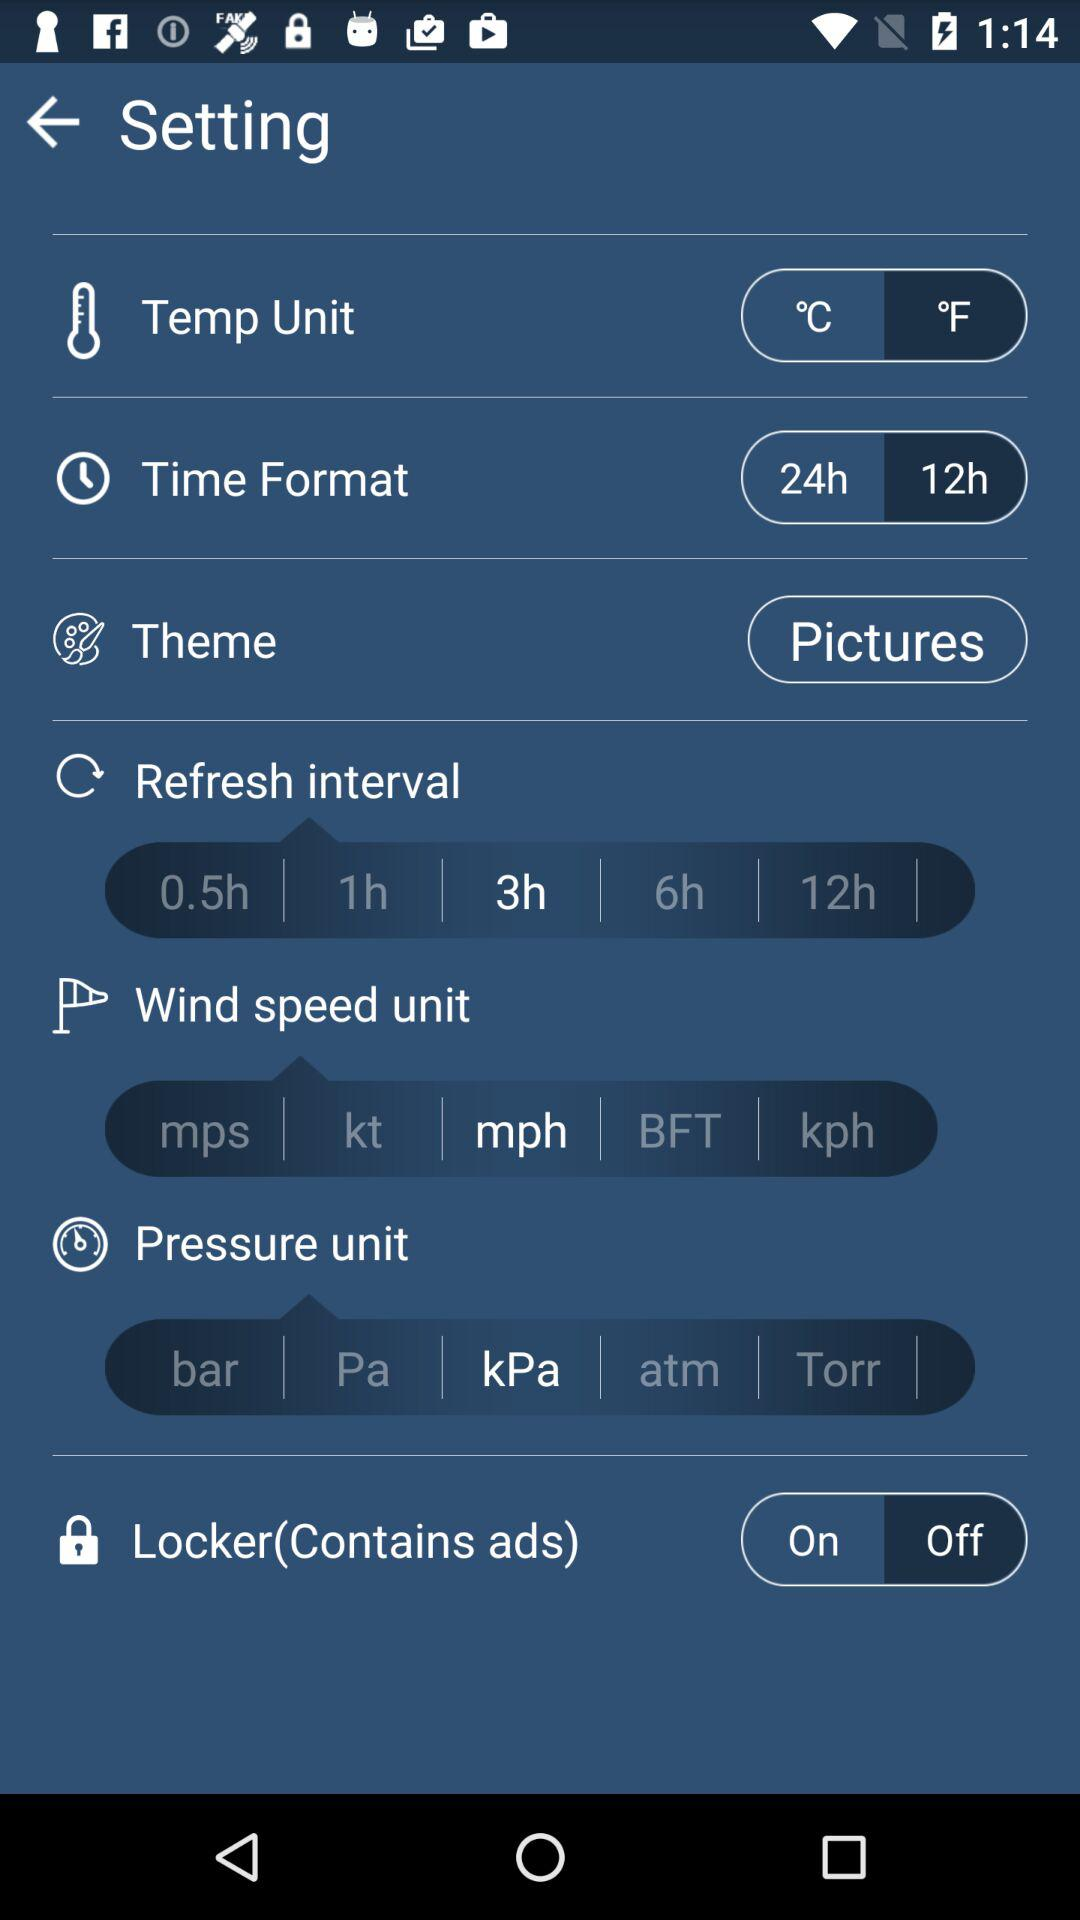What refresh interval has been chosen? The refresh interval that has been chosen is 3 hours. 